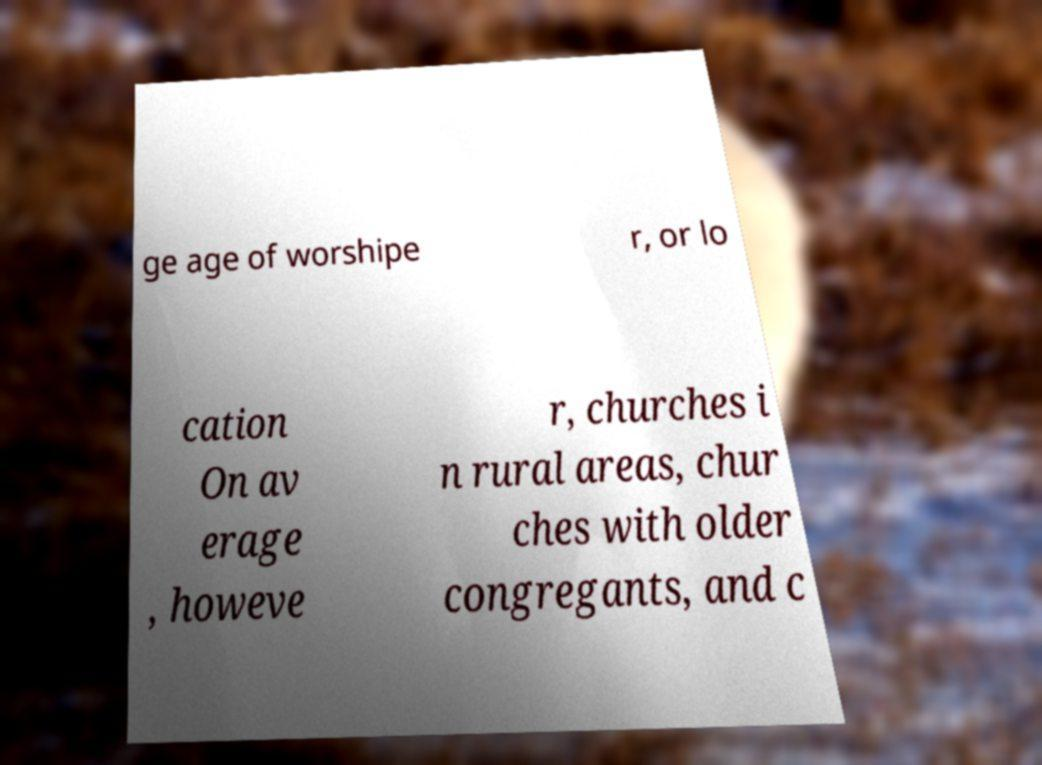I need the written content from this picture converted into text. Can you do that? ge age of worshipe r, or lo cation On av erage , howeve r, churches i n rural areas, chur ches with older congregants, and c 